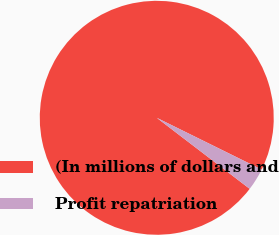Convert chart to OTSL. <chart><loc_0><loc_0><loc_500><loc_500><pie_chart><fcel>(In millions of dollars and<fcel>Profit repatriation<nl><fcel>96.91%<fcel>3.09%<nl></chart> 